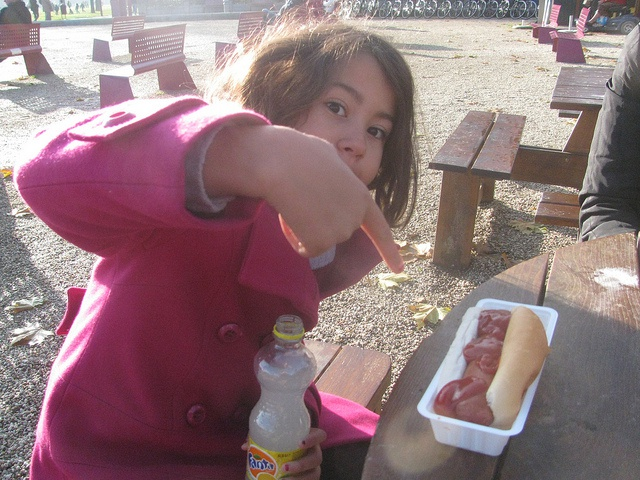Describe the objects in this image and their specific colors. I can see people in lightgray, maroon, brown, gray, and purple tones, dining table in lightgray, gray, darkgray, and tan tones, hot dog in lightgray, brown, darkgray, and tan tones, bench in lightgray, gray, and darkgray tones, and bottle in lightgray and gray tones in this image. 